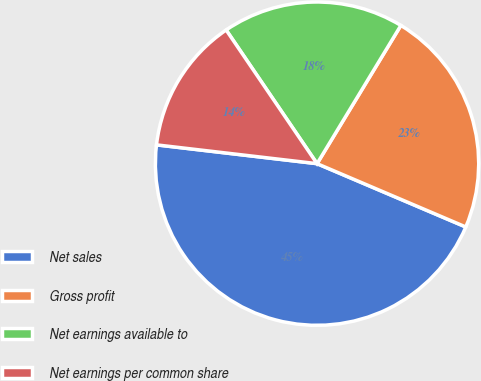Convert chart. <chart><loc_0><loc_0><loc_500><loc_500><pie_chart><fcel>Net sales<fcel>Gross profit<fcel>Net earnings available to<fcel>Net earnings per common share<nl><fcel>45.45%<fcel>22.73%<fcel>18.18%<fcel>13.64%<nl></chart> 